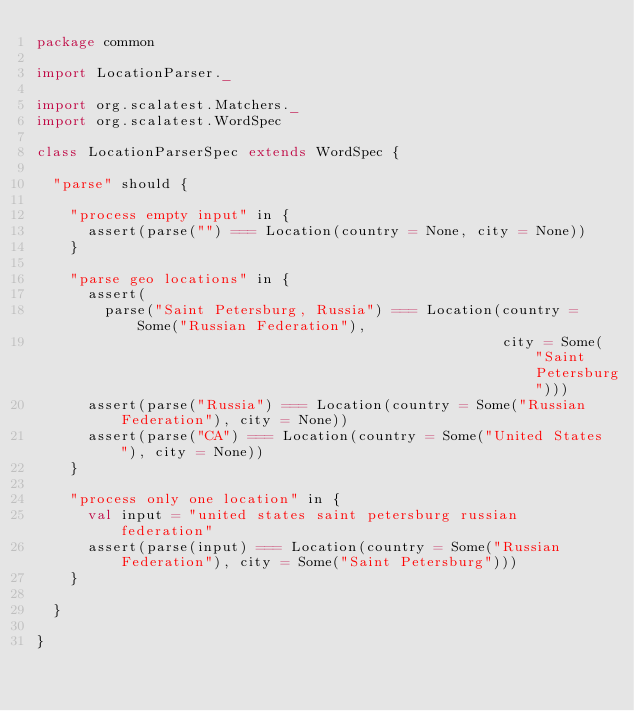<code> <loc_0><loc_0><loc_500><loc_500><_Scala_>package common

import LocationParser._

import org.scalatest.Matchers._
import org.scalatest.WordSpec

class LocationParserSpec extends WordSpec {

  "parse" should {

    "process empty input" in {
      assert(parse("") === Location(country = None, city = None))
    }

    "parse geo locations" in {
      assert(
        parse("Saint Petersburg, Russia") === Location(country = Some("Russian Federation"),
                                                       city = Some("Saint Petersburg")))
      assert(parse("Russia") === Location(country = Some("Russian Federation"), city = None))
      assert(parse("CA") === Location(country = Some("United States"), city = None))
    }

    "process only one location" in {
      val input = "united states saint petersburg russian federation"
      assert(parse(input) === Location(country = Some("Russian Federation"), city = Some("Saint Petersburg")))
    }

  }

}
</code> 